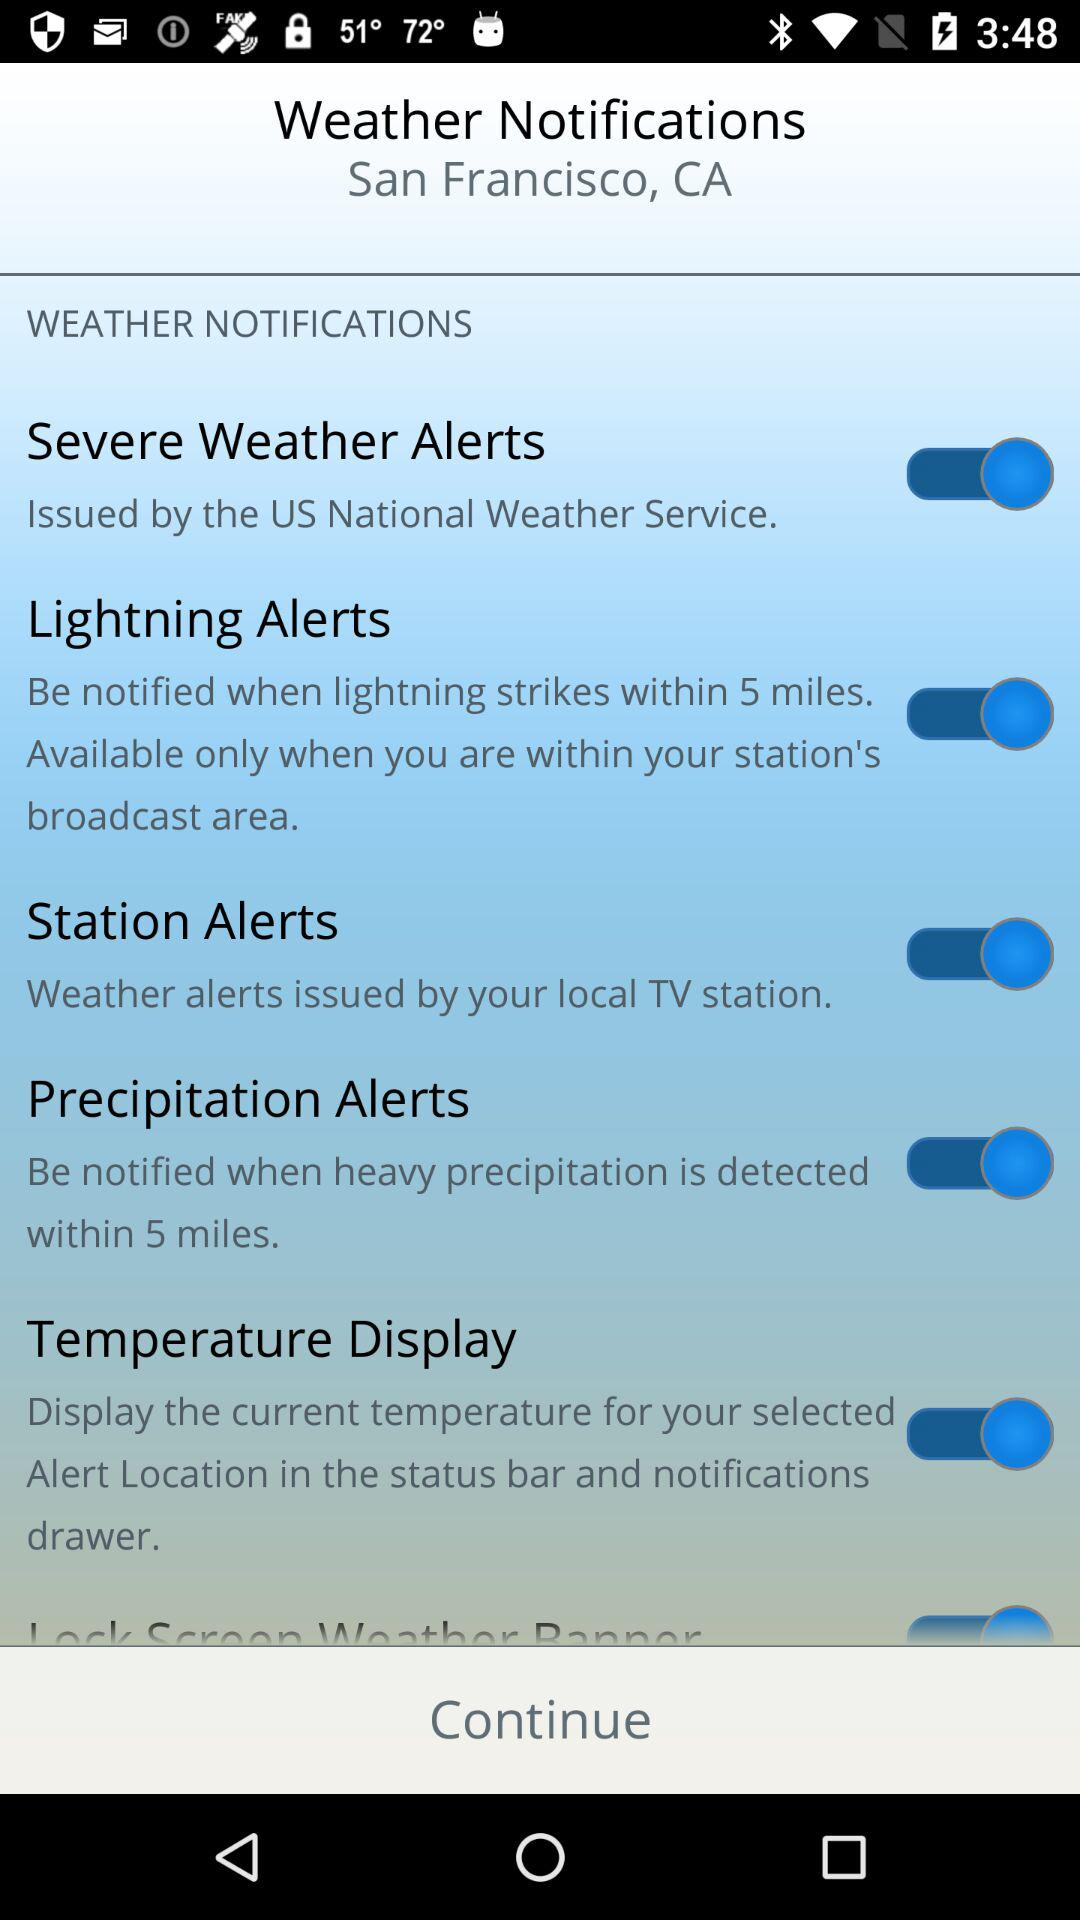What is the status of the "Station Alerts"? The status of the "Station Alerts" is "on". 